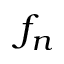<formula> <loc_0><loc_0><loc_500><loc_500>f _ { n }</formula> 